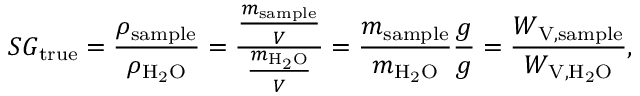<formula> <loc_0><loc_0><loc_500><loc_500>S G _ { t r u e } = { \frac { \rho _ { s a m p l e } } { \rho _ { H _ { 2 } O } } } = { \frac { \frac { m _ { s a m p l e } } { V } } { \frac { m _ { H _ { 2 } O } } { V } } } = { \frac { m _ { s a m p l e } } { m _ { H _ { 2 } O } } } { \frac { g } { g } } = { \frac { W _ { V , { s a m p l e } } } { W _ { V , H _ { 2 } O } } } ,</formula> 